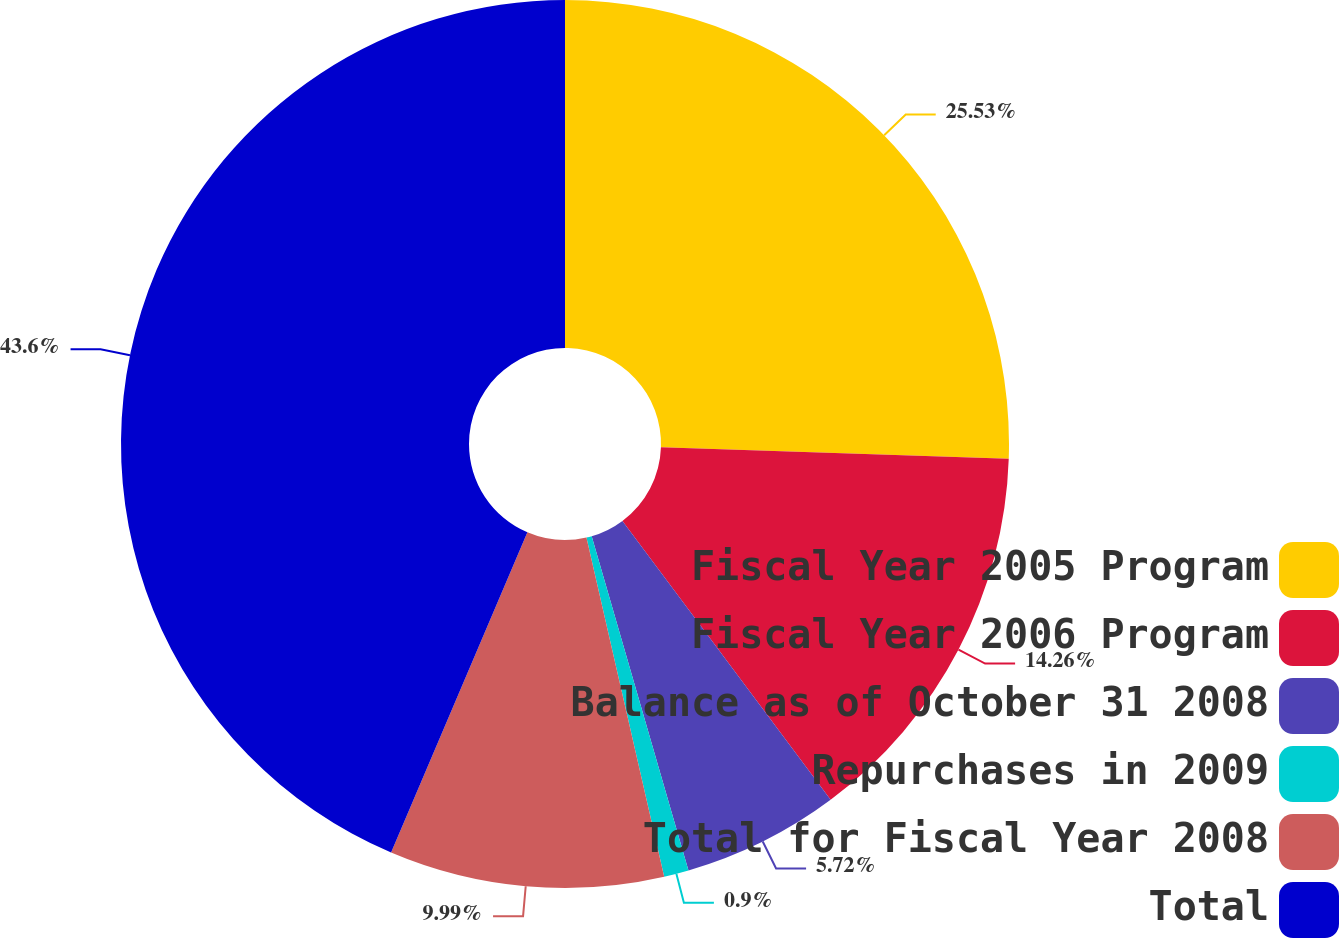Convert chart to OTSL. <chart><loc_0><loc_0><loc_500><loc_500><pie_chart><fcel>Fiscal Year 2005 Program<fcel>Fiscal Year 2006 Program<fcel>Balance as of October 31 2008<fcel>Repurchases in 2009<fcel>Total for Fiscal Year 2008<fcel>Total<nl><fcel>25.53%<fcel>14.26%<fcel>5.72%<fcel>0.9%<fcel>9.99%<fcel>43.59%<nl></chart> 